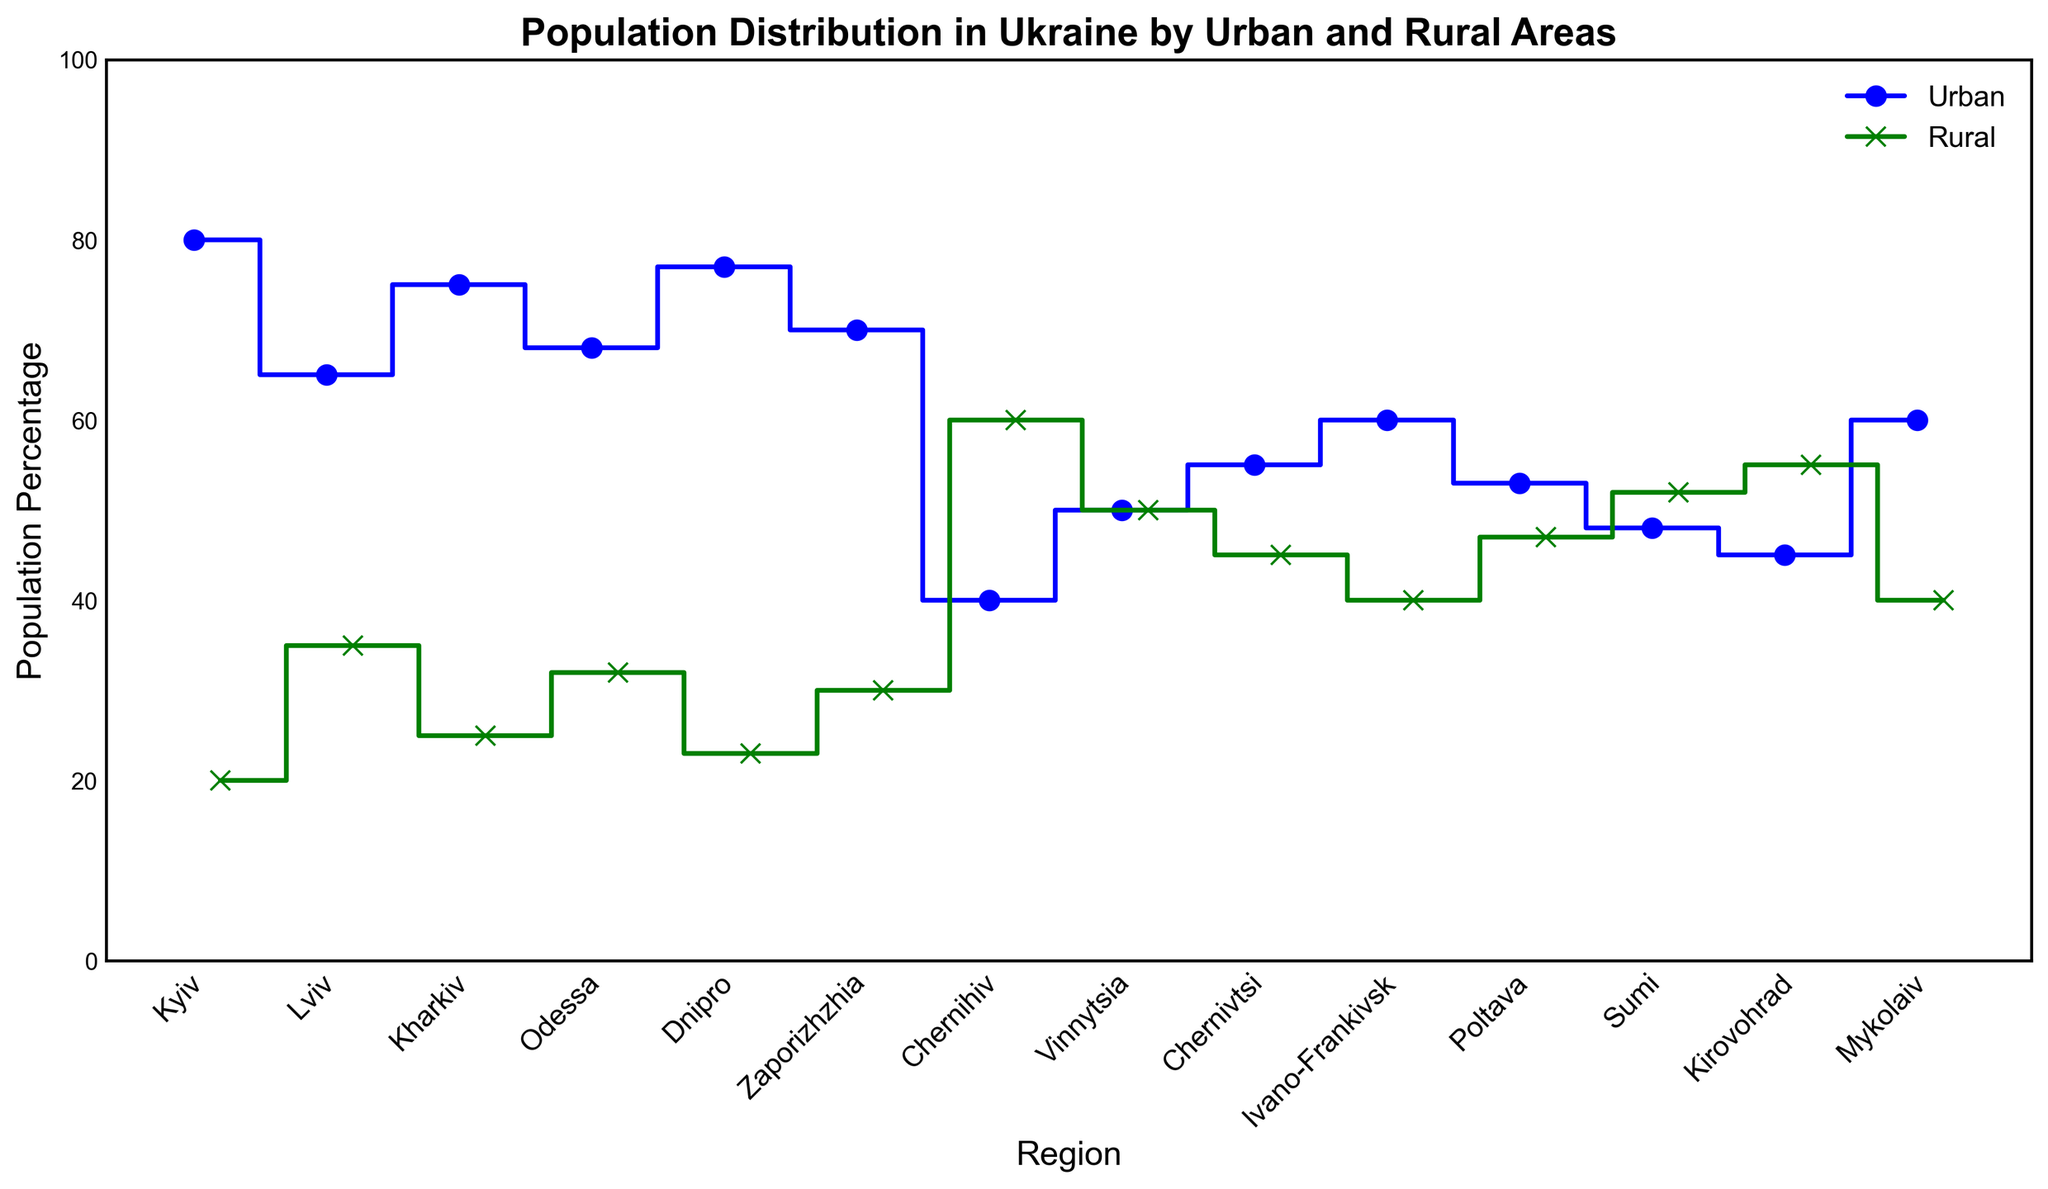Which region has the highest urban population percentage? Look at the plot and find the region with the highest point on the blue line representing the urban population. Kyiv has the highest urban percentage at 80%.
Answer: Kyiv Which region has a higher rural population percentage, Vinnytsia or Mykolaiv? Compare the points on the green line representing the rural population percentage for both regions. Vinnytsia and Mykolaiv are tied at 50%.
Answer: Vinnytsia and Mykolaiv What is the average urban population percentage across all regions? Add the urban population percentages (80 + 65 + 75 + 68 + 77 + 70 + 40 + 50 + 55 + 60 + 53 + 48 + 45 + 60) and divide by the number of regions (14). The total sum is 846. So, the average is 846/14 = 60.43%.
Answer: 60.43% How does the rural population percentage in Lviv compare to Kyiv? Compare the points on the green line representing the rural population percentage for both regions. Lviv has a rural population percentage of 35%, while Kyiv has 20%. Lviv's rural percentage is higher.
Answer: Lviv What is the total population percentage for urban and rural areas in Zaporizhzhia? Sum the urban and rural population percentages for Zaporizhzhia (70% urban + 30% rural). The total is 70+30 = 100%.
Answer: 100% Which region has a more balanced distribution between urban and rural populations? Look for the region where the urban and rural percentages are closest to each other. Vinnytsia has an equal distribution with 50% each.
Answer: Vinnytsia Which region has the smallest rural population percentage? Look on the green line for the lowest point representing the rural population percentage. Kyiv has the smallest rural percentage at 20%.
Answer: Kyiv Are there more regions with a higher urban population percentage than rural? Count the regions where urban percentages are greater than their rural counterparts. There are 11 regions with higher urban population percentages and 3 with higher rural population percentages.
Answer: Yes Is the urban population percentage in Odessa closer to that in Kharkiv or to Lviv? Compare the urban percentages: Odessa (68%), Kharkiv (75%), and Lviv (65%). Odessa's urban percentage (68%) is closer to Lviv (65%) than to Kharkiv (75%).
Answer: Lviv 